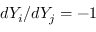<formula> <loc_0><loc_0><loc_500><loc_500>d Y _ { i } / d Y _ { j } = - 1</formula> 